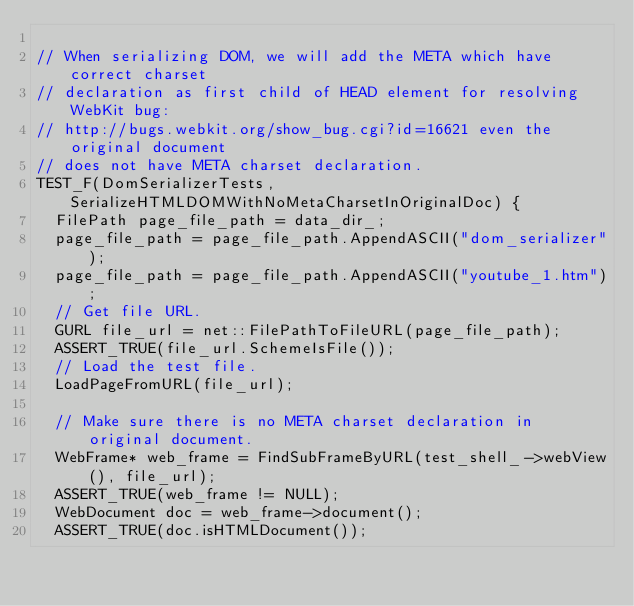Convert code to text. <code><loc_0><loc_0><loc_500><loc_500><_C++_>
// When serializing DOM, we will add the META which have correct charset
// declaration as first child of HEAD element for resolving WebKit bug:
// http://bugs.webkit.org/show_bug.cgi?id=16621 even the original document
// does not have META charset declaration.
TEST_F(DomSerializerTests, SerializeHTMLDOMWithNoMetaCharsetInOriginalDoc) {
  FilePath page_file_path = data_dir_;
  page_file_path = page_file_path.AppendASCII("dom_serializer");
  page_file_path = page_file_path.AppendASCII("youtube_1.htm");
  // Get file URL.
  GURL file_url = net::FilePathToFileURL(page_file_path);
  ASSERT_TRUE(file_url.SchemeIsFile());
  // Load the test file.
  LoadPageFromURL(file_url);

  // Make sure there is no META charset declaration in original document.
  WebFrame* web_frame = FindSubFrameByURL(test_shell_->webView(), file_url);
  ASSERT_TRUE(web_frame != NULL);
  WebDocument doc = web_frame->document();
  ASSERT_TRUE(doc.isHTMLDocument());</code> 